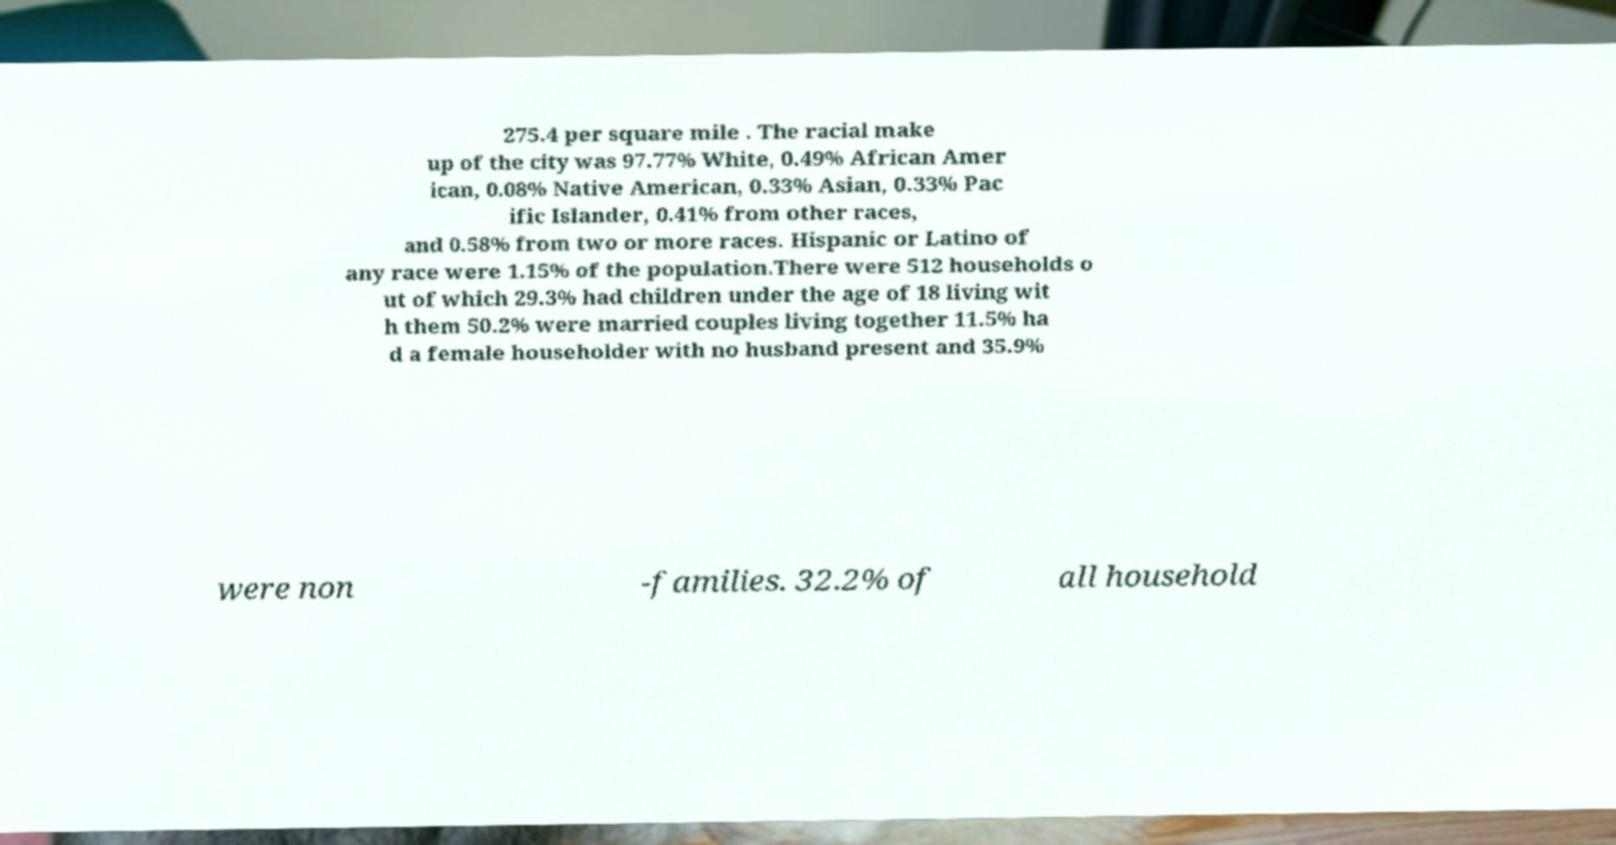What messages or text are displayed in this image? I need them in a readable, typed format. 275.4 per square mile . The racial make up of the city was 97.77% White, 0.49% African Amer ican, 0.08% Native American, 0.33% Asian, 0.33% Pac ific Islander, 0.41% from other races, and 0.58% from two or more races. Hispanic or Latino of any race were 1.15% of the population.There were 512 households o ut of which 29.3% had children under the age of 18 living wit h them 50.2% were married couples living together 11.5% ha d a female householder with no husband present and 35.9% were non -families. 32.2% of all household 